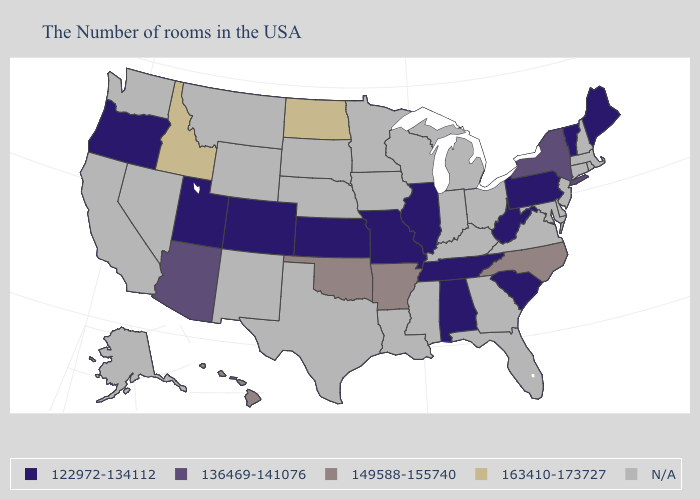What is the highest value in the MidWest ?
Keep it brief. 163410-173727. Name the states that have a value in the range 149588-155740?
Write a very short answer. North Carolina, Arkansas, Oklahoma, Hawaii. What is the highest value in the South ?
Write a very short answer. 149588-155740. What is the value of Oregon?
Concise answer only. 122972-134112. Name the states that have a value in the range 136469-141076?
Short answer required. New York, Arizona. What is the value of Idaho?
Answer briefly. 163410-173727. What is the highest value in the USA?
Quick response, please. 163410-173727. What is the value of Indiana?
Write a very short answer. N/A. Name the states that have a value in the range 136469-141076?
Be succinct. New York, Arizona. Among the states that border Colorado , does Arizona have the highest value?
Answer briefly. No. Which states hav the highest value in the South?
Quick response, please. North Carolina, Arkansas, Oklahoma. What is the lowest value in the USA?
Be succinct. 122972-134112. Does Idaho have the highest value in the West?
Keep it brief. Yes. What is the highest value in the USA?
Write a very short answer. 163410-173727. Does Kansas have the highest value in the MidWest?
Keep it brief. No. 